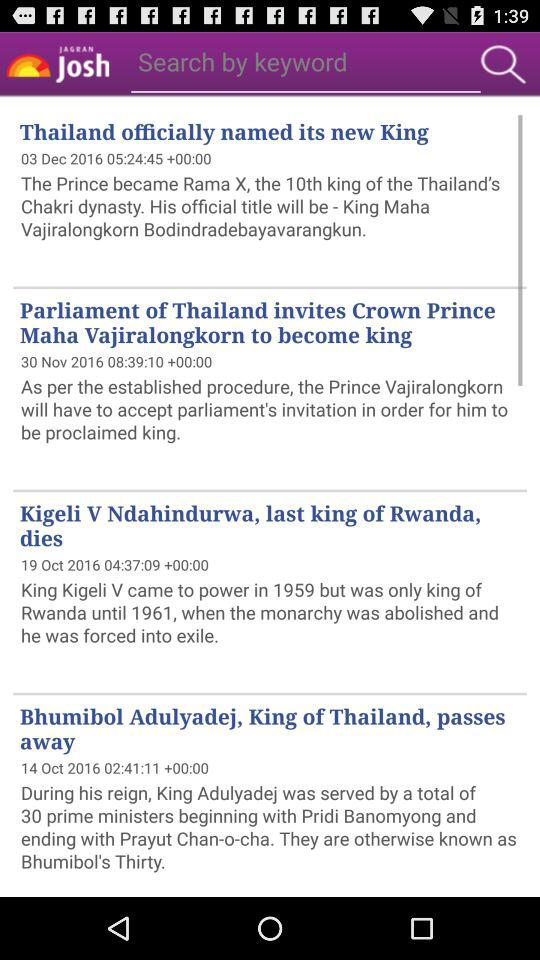Who is the tenth king of Thailand? The tenth king of Thailand is King Maha Vajiralongkorn Bodindradebayavarangkun. 